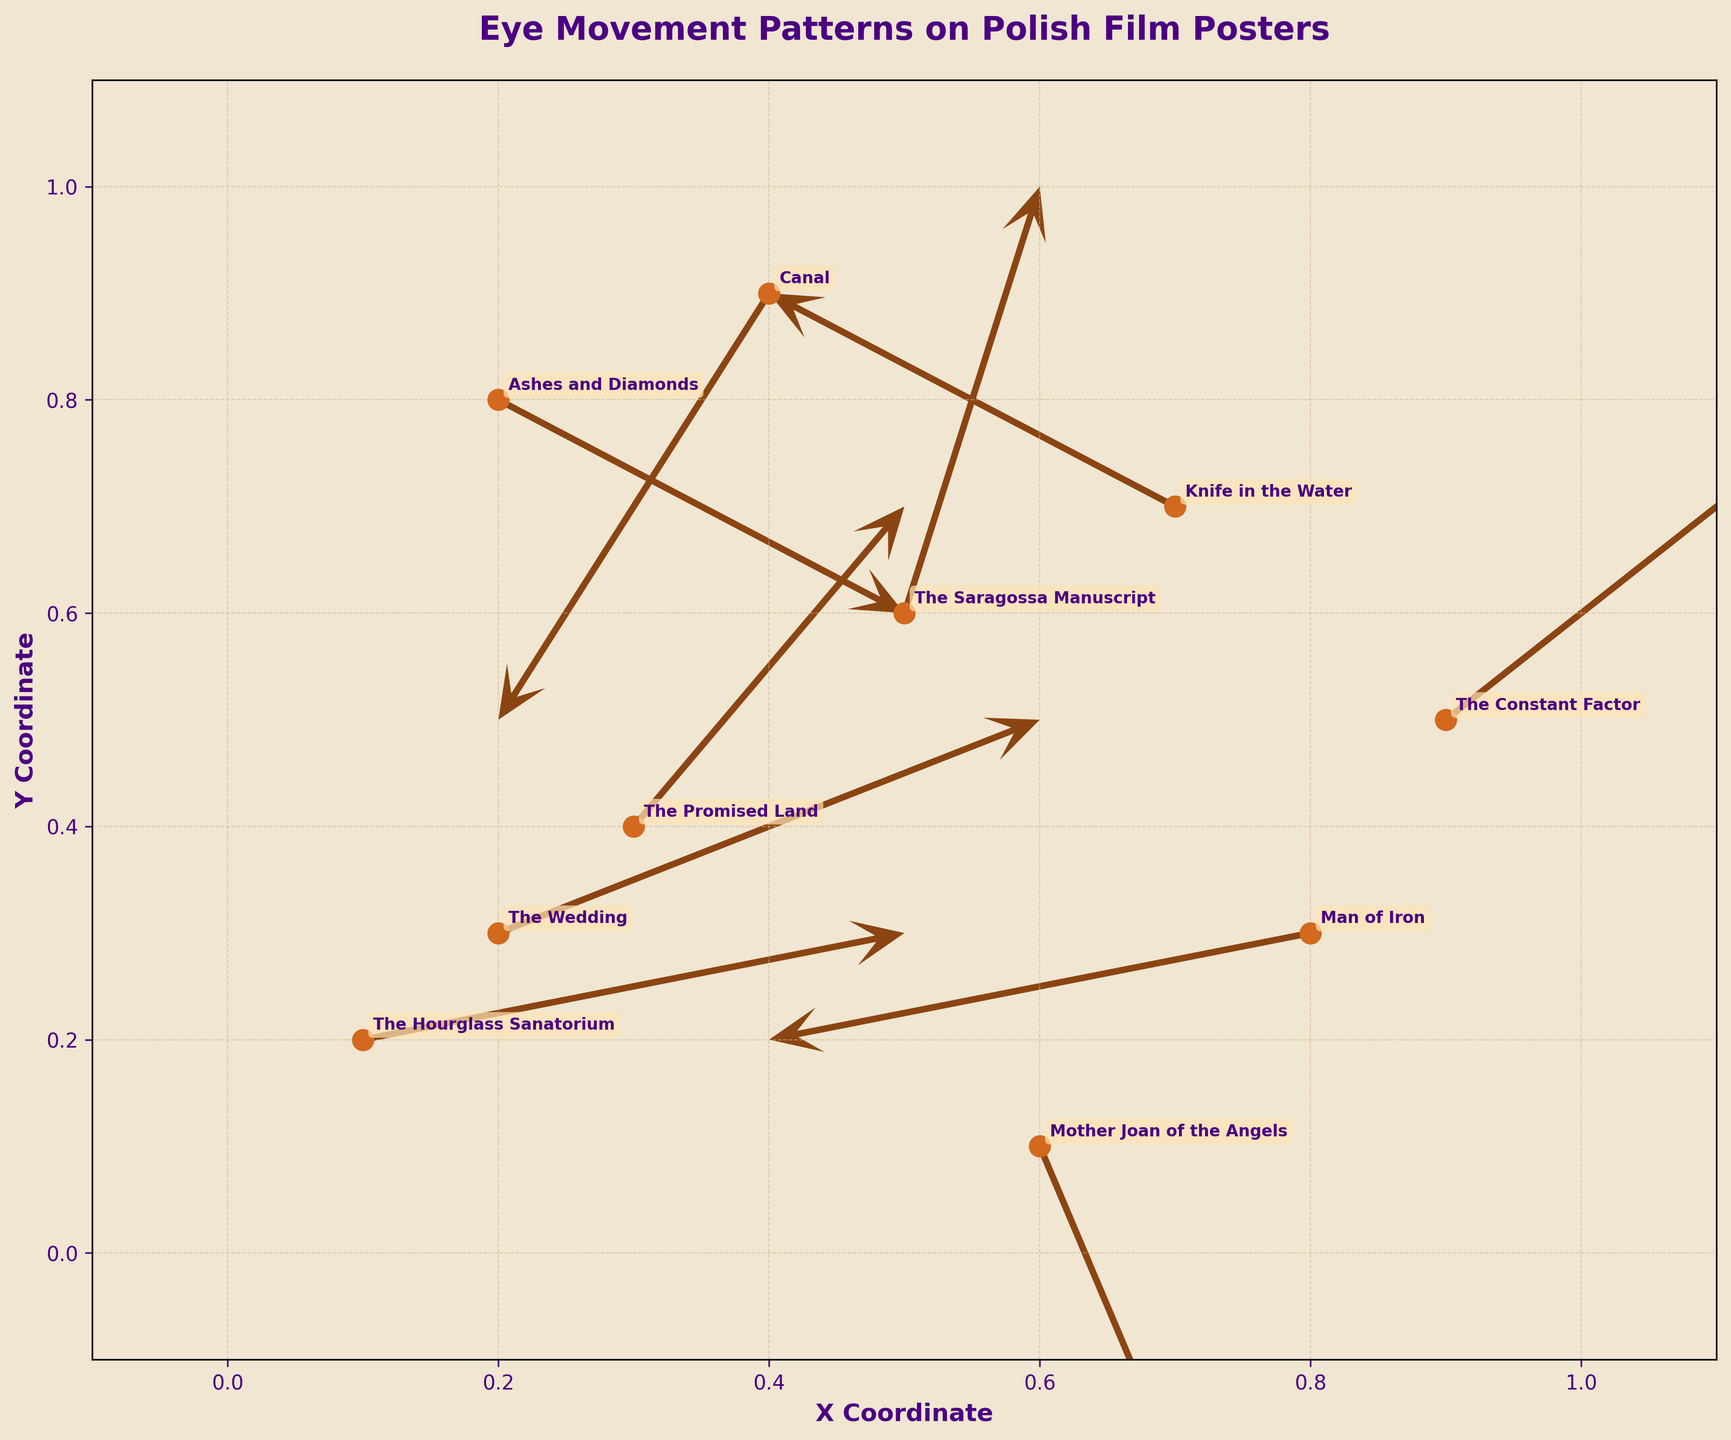What is the title of the plot? The title is clearly visible on top of the plot. It reads "Eye Movement Patterns on Polish Film Posters".
Answer: Eye Movement Patterns on Polish Film Posters How many data points are represented in the plot? The number of scatter points corresponds to the number of data points. Each point is a starting point for a quiver arrow. By counting them, we find there are 10 data points.
Answer: 10 What are the colors used for the arrows and scatter points? The arrows are a brown color and the scatter points are a dark orange color.
Answer: Brown and Dark Orange Which two posters have the starting points closest to each other on the plot? By observing the scatter points and annotations, "The Promised Land" (at 0.3, 0.4) and "The Wedding" (at 0.2, 0.3) are the closest to each other.
Answer: The Promised Land and The Wedding Which poster's eye movement indicates the highest y-coordinate increase? The largest increase in y-coordinate is given by the vector with the maximum positive value in the y direction. "The Saragossa Manuscript" shows an increase of 0.4 in the y direction.
Answer: The Saragossa Manuscript Compare the directions of the arrows for "Ashes and Diamonds" and "The Saragossa Manuscript". Which one moves more horizontally? "Ashes and Diamonds" has u=0.3 and v=-0.2, and "The Saragossa Manuscript" has u=0.1 and v=0.4. Since 0.3 is greater than 0.1, "Ashes and Diamonds" moves more horizontally.
Answer: Ashes and Diamonds Out of the posters listed, which one shows a decrease in both x and y coordinates? By checking the arrows with both negative u and v components, "Man of Iron" (u=-0.4, v=-0.1) is the poster that moves in both negative x and y directions.
Answer: Man of Iron What is the average of the x-coordinates of all starting points? To find the average x-coordinate: (0.2 + 0.5 + 0.8 + 0.3 + 0.7 + 0.1 + 0.6 + 0.4 + 0.9 + 0.2)/10 = 0.47.
Answer: 0.47 For which poster does the eye movement vector have the smallest magnitude, and what is its value? Calculate the magnitudes: sqrt(0.3² + (-0.2)²) = 0.361, sqrt(0.1² + 0.4²) = 0.412, and so on. "Ashes and Diamonds" has the smallest magnitude sqrt(0.3² + (-0.2)²) = 0.36.
Answer: Ashes and Diamonds, 0.36 What is the color of the annotation boxes, and what font attributes are used for the text? The annotation boxes are a light beige color, and the text inside the boxes is bold, small-sized, and dark violet color.
Answer: Light beige, bold, small-sized, dark violet 